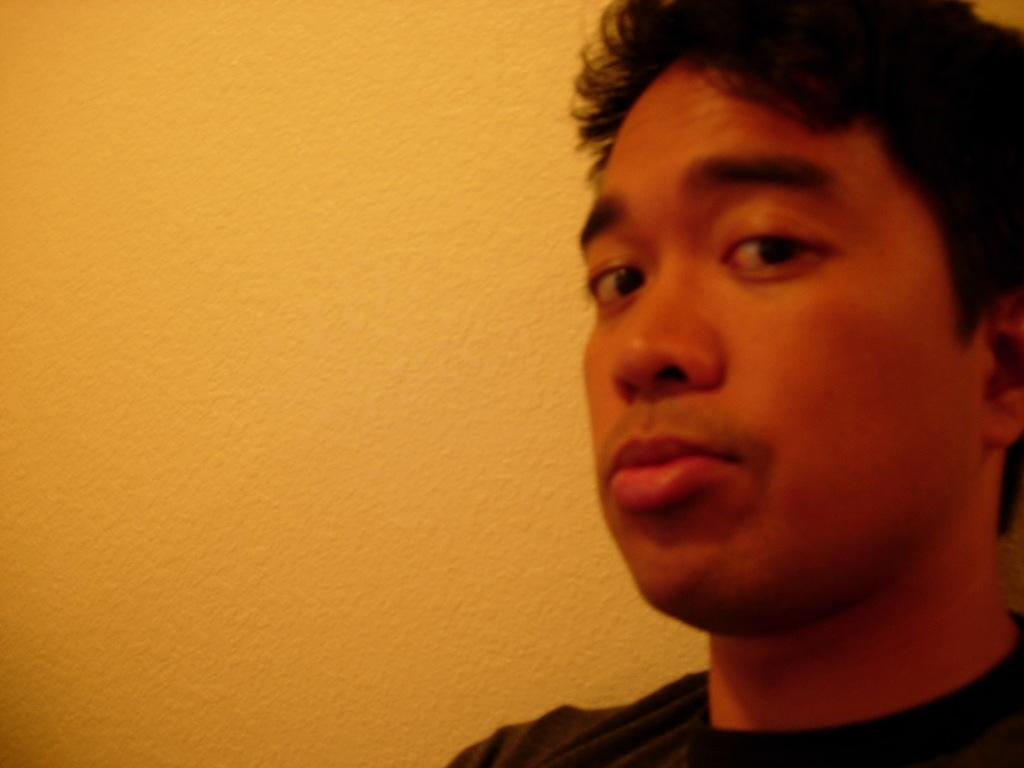Who is present in the image? There is a man in the image. What can be seen in the background of the image? There is a wall in the background of the image. What type of soap is the man using in the image? There is no soap present in the image; it only features a man and a wall in the background. 